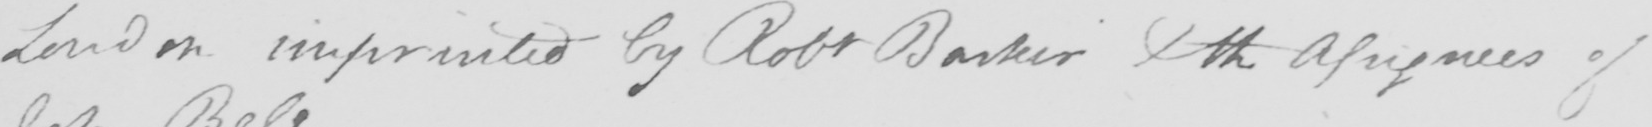Please transcribe the handwritten text in this image. London imprinted by Robt Barker Xth Assignees of 